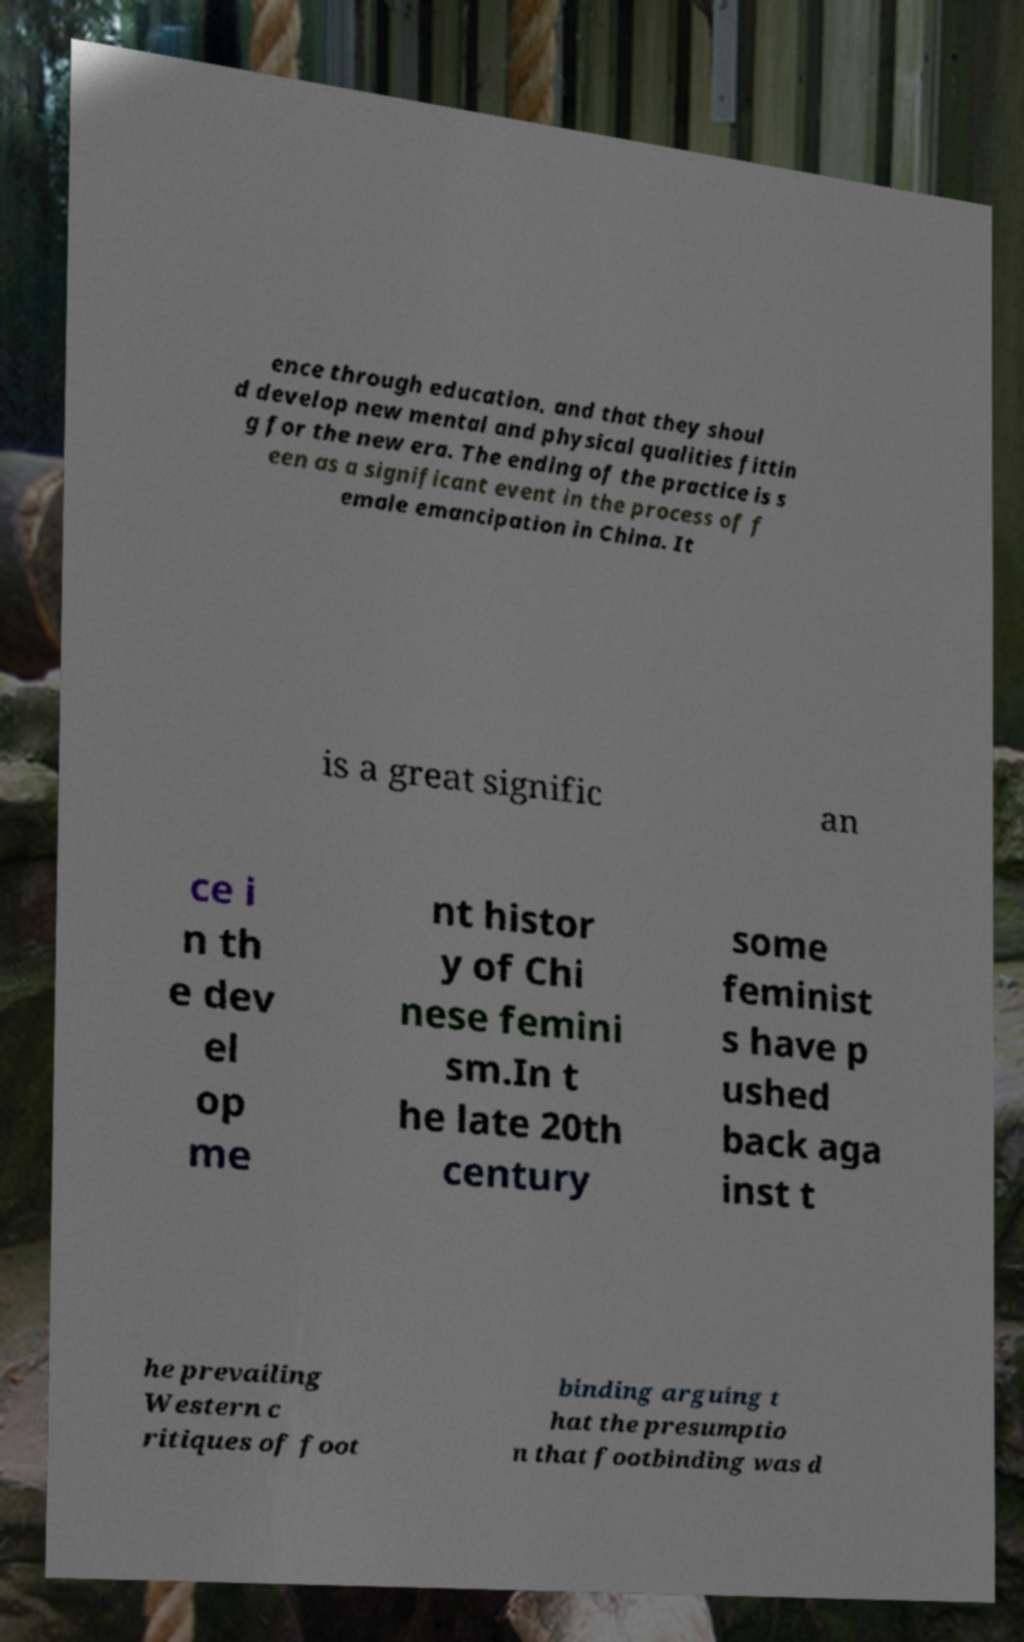Could you assist in decoding the text presented in this image and type it out clearly? ence through education, and that they shoul d develop new mental and physical qualities fittin g for the new era. The ending of the practice is s een as a significant event in the process of f emale emancipation in China. It is a great signific an ce i n th e dev el op me nt histor y of Chi nese femini sm.In t he late 20th century some feminist s have p ushed back aga inst t he prevailing Western c ritiques of foot binding arguing t hat the presumptio n that footbinding was d 